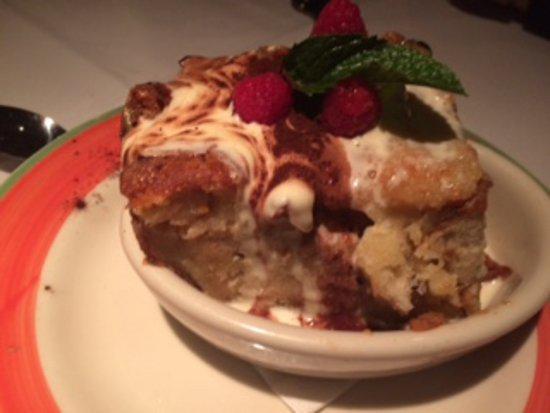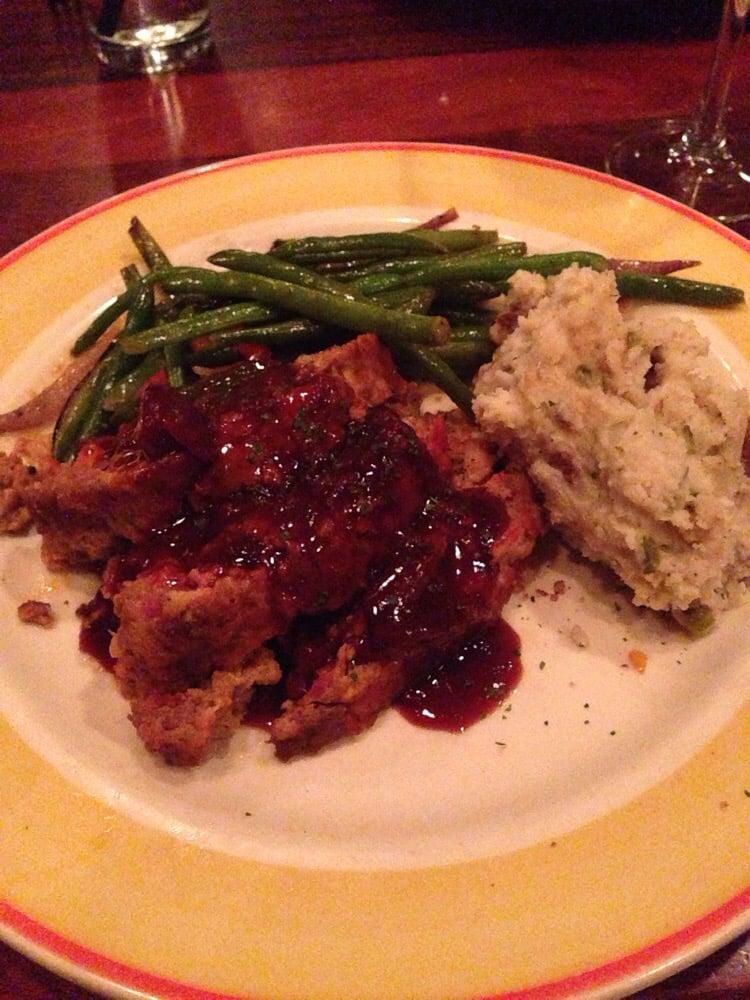The first image is the image on the left, the second image is the image on the right. Assess this claim about the two images: "The food in the image on the right is being served in a blue and white dish.". Correct or not? Answer yes or no. No. The first image is the image on the left, the second image is the image on the right. Analyze the images presented: Is the assertion "At least one image shows green beans next to meatloaf on a plate, and one plate has a royal blue band around it rimmed with red." valid? Answer yes or no. No. 